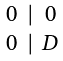<formula> <loc_0><loc_0><loc_500><loc_500>\begin{smallmatrix} 0 & | & 0 \\ \\ 0 & | & D \end{smallmatrix}</formula> 